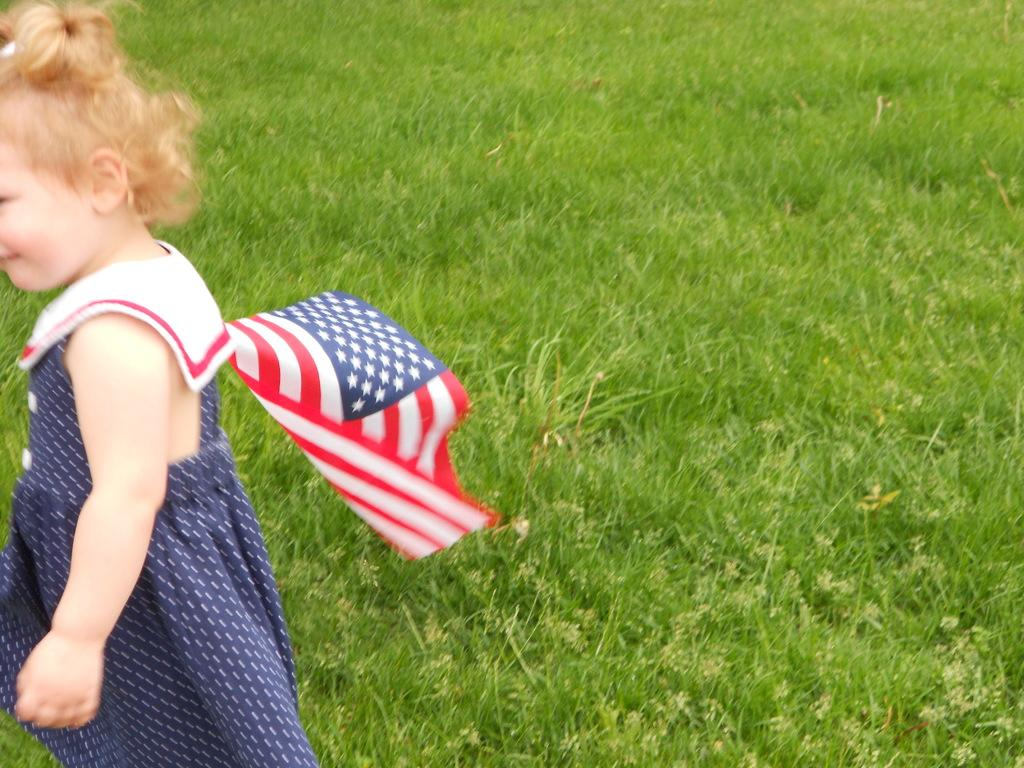What type of vegetation is visible in the image? There is grass in the image. Where is the kid located in the image? The kid is holding a flag on the left side of the image. What type of amusement can be seen in the image? There is no amusement park or ride present in the image; it features grass and a kid holding a flag. 